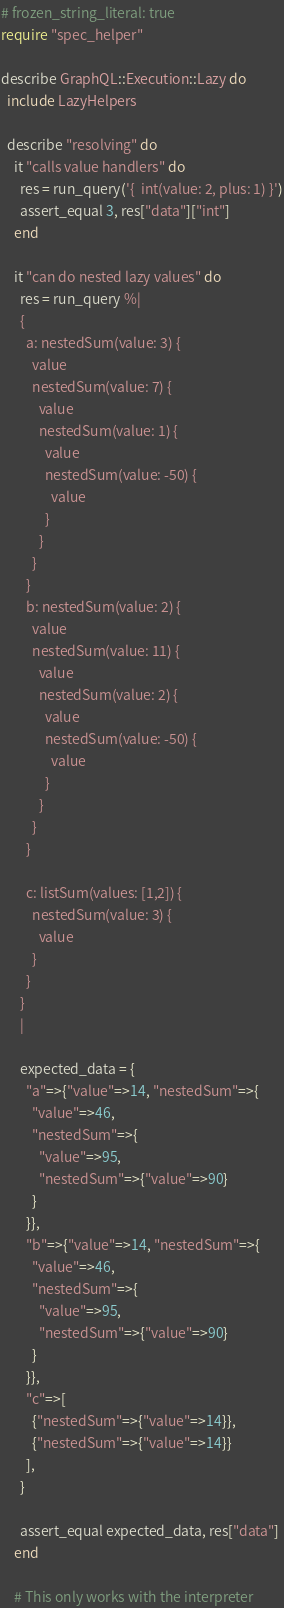<code> <loc_0><loc_0><loc_500><loc_500><_Ruby_># frozen_string_literal: true
require "spec_helper"

describe GraphQL::Execution::Lazy do
  include LazyHelpers

  describe "resolving" do
    it "calls value handlers" do
      res = run_query('{  int(value: 2, plus: 1) }')
      assert_equal 3, res["data"]["int"]
    end

    it "can do nested lazy values" do
      res = run_query %|
      {
        a: nestedSum(value: 3) {
          value
          nestedSum(value: 7) {
            value
            nestedSum(value: 1) {
              value
              nestedSum(value: -50) {
                value
              }
            }
          }
        }
        b: nestedSum(value: 2) {
          value
          nestedSum(value: 11) {
            value
            nestedSum(value: 2) {
              value
              nestedSum(value: -50) {
                value
              }
            }
          }
        }

        c: listSum(values: [1,2]) {
          nestedSum(value: 3) {
            value
          }
        }
      }
      |

      expected_data = {
        "a"=>{"value"=>14, "nestedSum"=>{
          "value"=>46,
          "nestedSum"=>{
            "value"=>95,
            "nestedSum"=>{"value"=>90}
          }
        }},
        "b"=>{"value"=>14, "nestedSum"=>{
          "value"=>46,
          "nestedSum"=>{
            "value"=>95,
            "nestedSum"=>{"value"=>90}
          }
        }},
        "c"=>[
          {"nestedSum"=>{"value"=>14}},
          {"nestedSum"=>{"value"=>14}}
        ],
      }

      assert_equal expected_data, res["data"]
    end

    # This only works with the interpreter</code> 